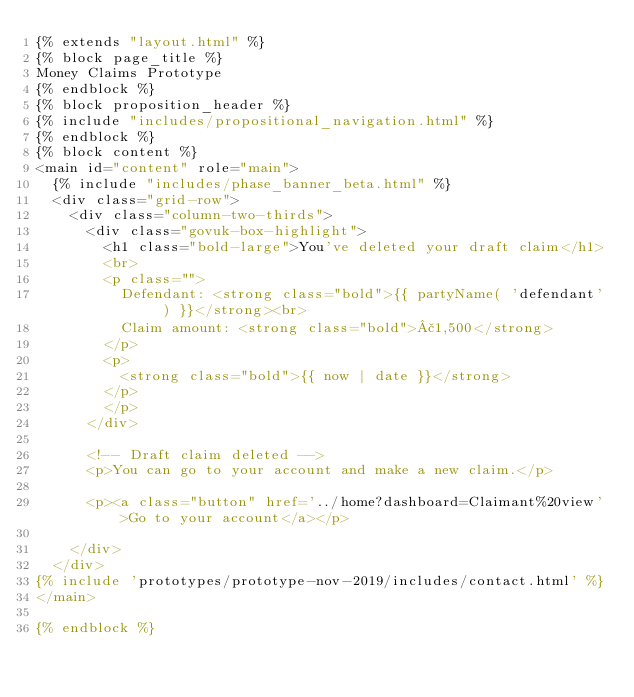<code> <loc_0><loc_0><loc_500><loc_500><_HTML_>{% extends "layout.html" %}
{% block page_title %}
Money Claims Prototype
{% endblock %}
{% block proposition_header %}
{% include "includes/propositional_navigation.html" %}
{% endblock %}
{% block content %}
<main id="content" role="main">
  {% include "includes/phase_banner_beta.html" %}
  <div class="grid-row">
    <div class="column-two-thirds">
      <div class="govuk-box-highlight">
        <h1 class="bold-large">You've deleted your draft claim</h1>
        <br>
        <p class="">
          Defendant: <strong class="bold">{{ partyName( 'defendant' ) }}</strong><br>
          Claim amount: <strong class="bold">£1,500</strong>
        </p>
        <p>
          <strong class="bold">{{ now | date }}</strong>
        </p>
        </p>
      </div>

      <!-- Draft claim deleted -->
      <p>You can go to your account and make a new claim.</p>

      <p><a class="button" href='../home?dashboard=Claimant%20view'>Go to your account</a></p>

    </div>
  </div>
{% include 'prototypes/prototype-nov-2019/includes/contact.html' %}
</main>

{% endblock %}</code> 